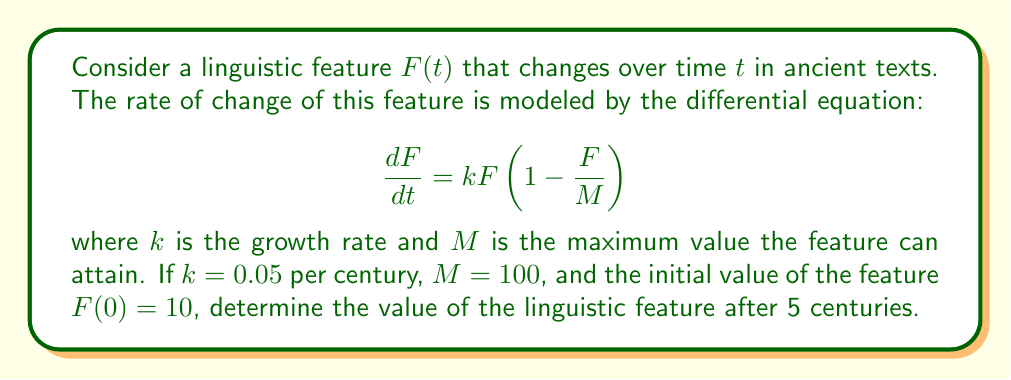Give your solution to this math problem. To solve this problem, we need to use the logistic growth model, which is described by the given differential equation. This model is often used in population dynamics but can be applied to linguistic features as well.

1. The differential equation given is:
   $$\frac{dF}{dt} = kF(1 - \frac{F}{M})$$

2. The solution to this equation is the logistic function:
   $$F(t) = \frac{M}{1 + (\frac{M}{F_0} - 1)e^{-kt}}$$
   where $F_0$ is the initial value of $F$ at $t = 0$.

3. We are given:
   $k = 0.05$ per century
   $M = 100$
   $F_0 = F(0) = 10$
   $t = 5$ centuries

4. Let's substitute these values into the logistic function:
   $$F(5) = \frac{100}{1 + (\frac{100}{10} - 1)e^{-0.05 \cdot 5}}$$

5. Simplify:
   $$F(5) = \frac{100}{1 + 9e^{-0.25}}$$

6. Calculate $e^{-0.25} \approx 0.7788$

7. Substitute this value:
   $$F(5) = \frac{100}{1 + 9 \cdot 0.7788} = \frac{100}{8.0092}$$

8. Calculate the final result:
   $$F(5) \approx 12.4859$$

Therefore, after 5 centuries, the value of the linguistic feature will be approximately 12.4859.
Answer: $F(5) \approx 12.4859$ 